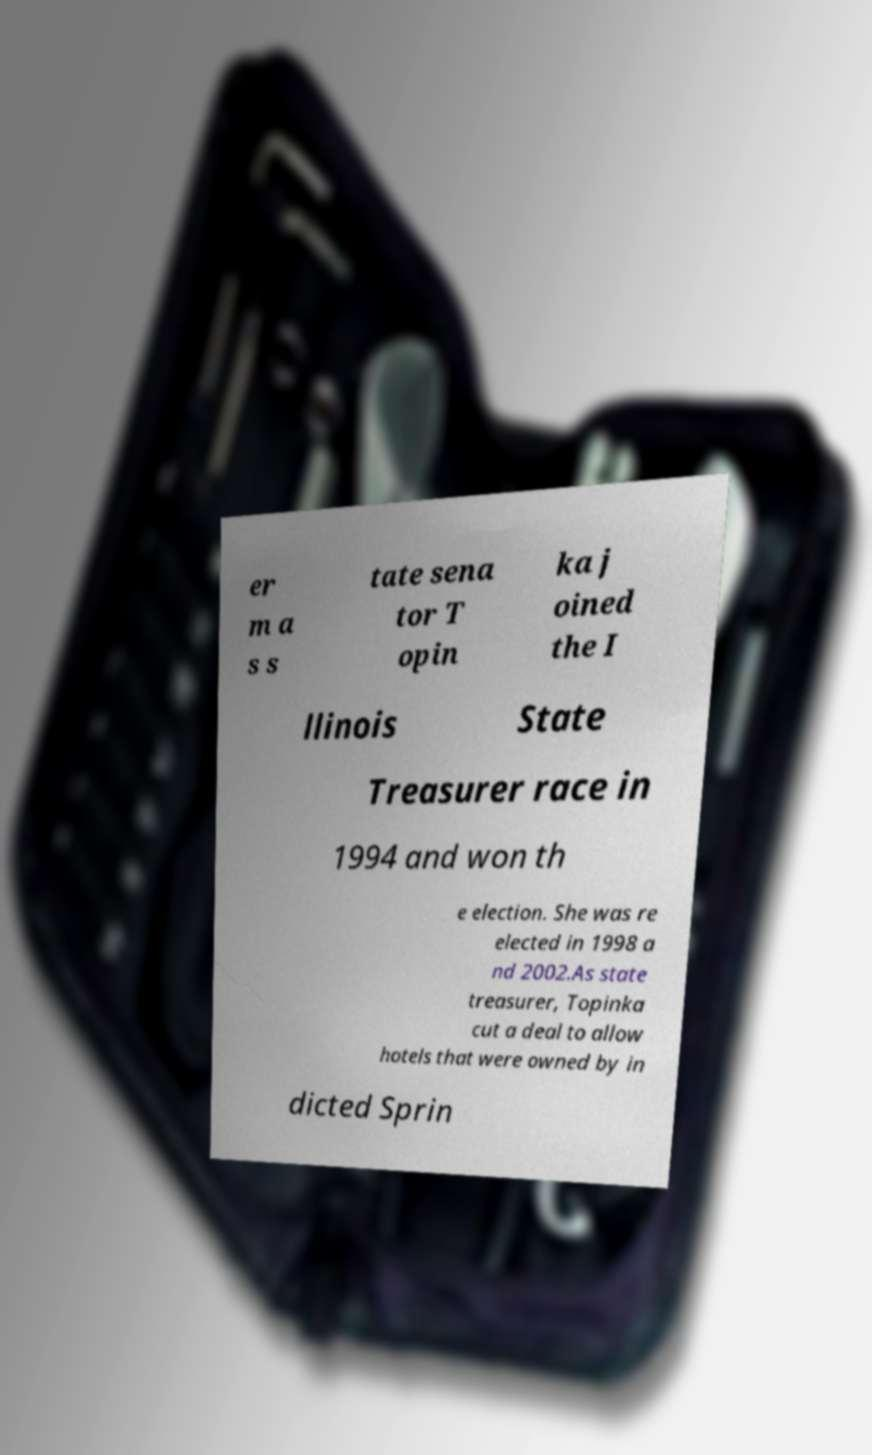There's text embedded in this image that I need extracted. Can you transcribe it verbatim? er m a s s tate sena tor T opin ka j oined the I llinois State Treasurer race in 1994 and won th e election. She was re elected in 1998 a nd 2002.As state treasurer, Topinka cut a deal to allow hotels that were owned by in dicted Sprin 